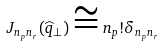Convert formula to latex. <formula><loc_0><loc_0><loc_500><loc_500>J _ { n _ { p } n _ { r } } ( \widehat { q } _ { \perp } ) \cong n _ { p } ! \delta _ { n _ { p } n _ { r } }</formula> 